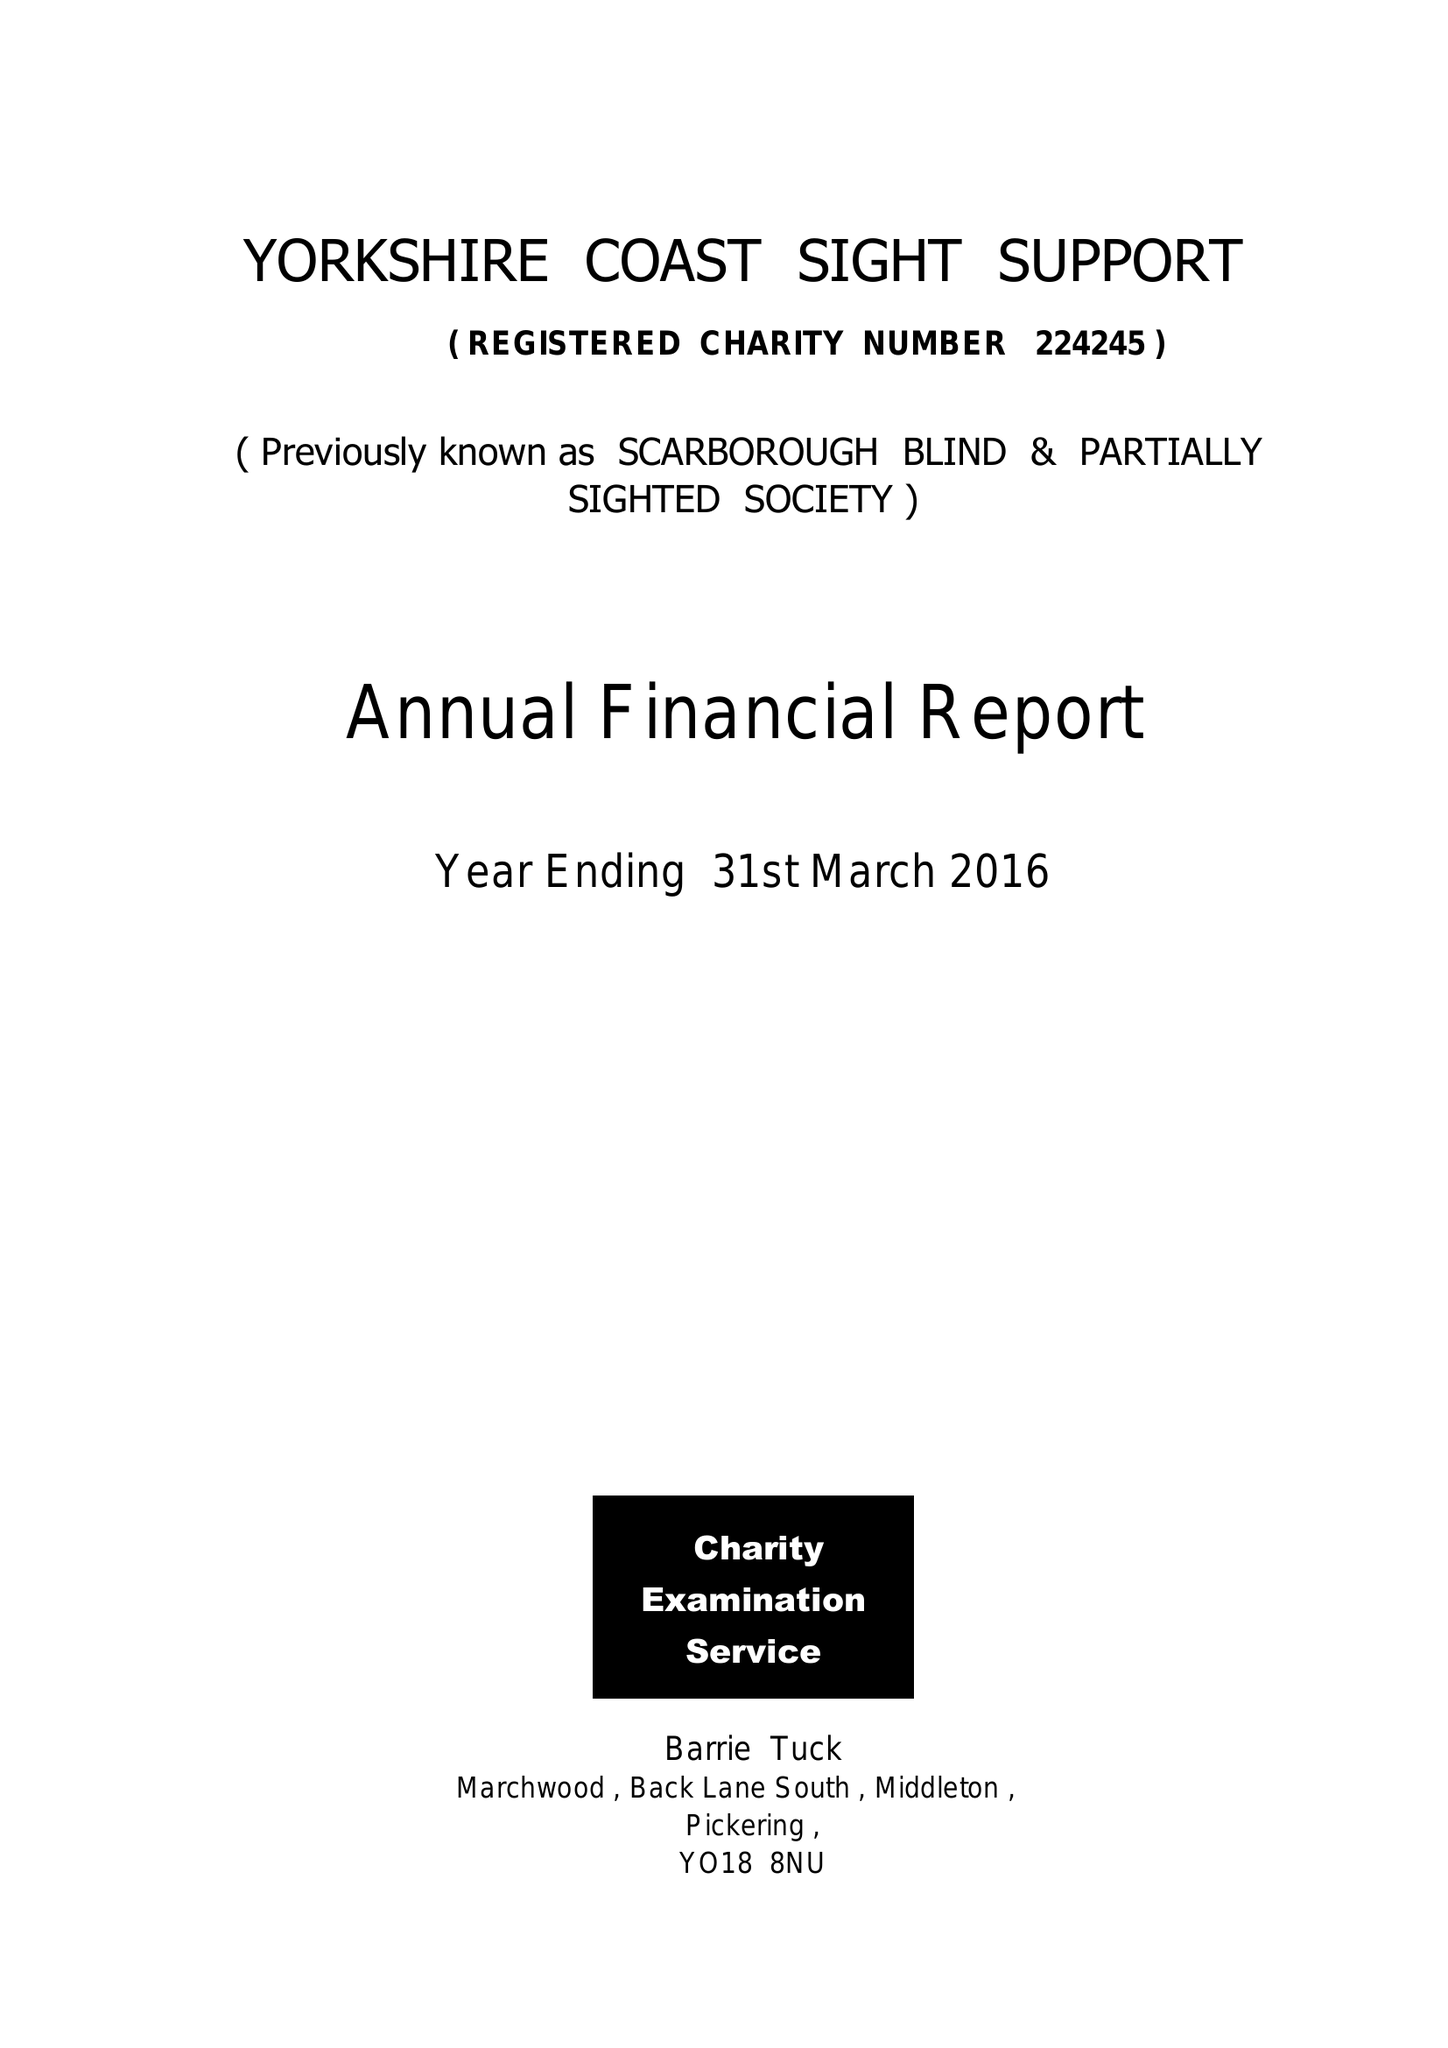What is the value for the address__post_town?
Answer the question using a single word or phrase. SCARBOROUGH 